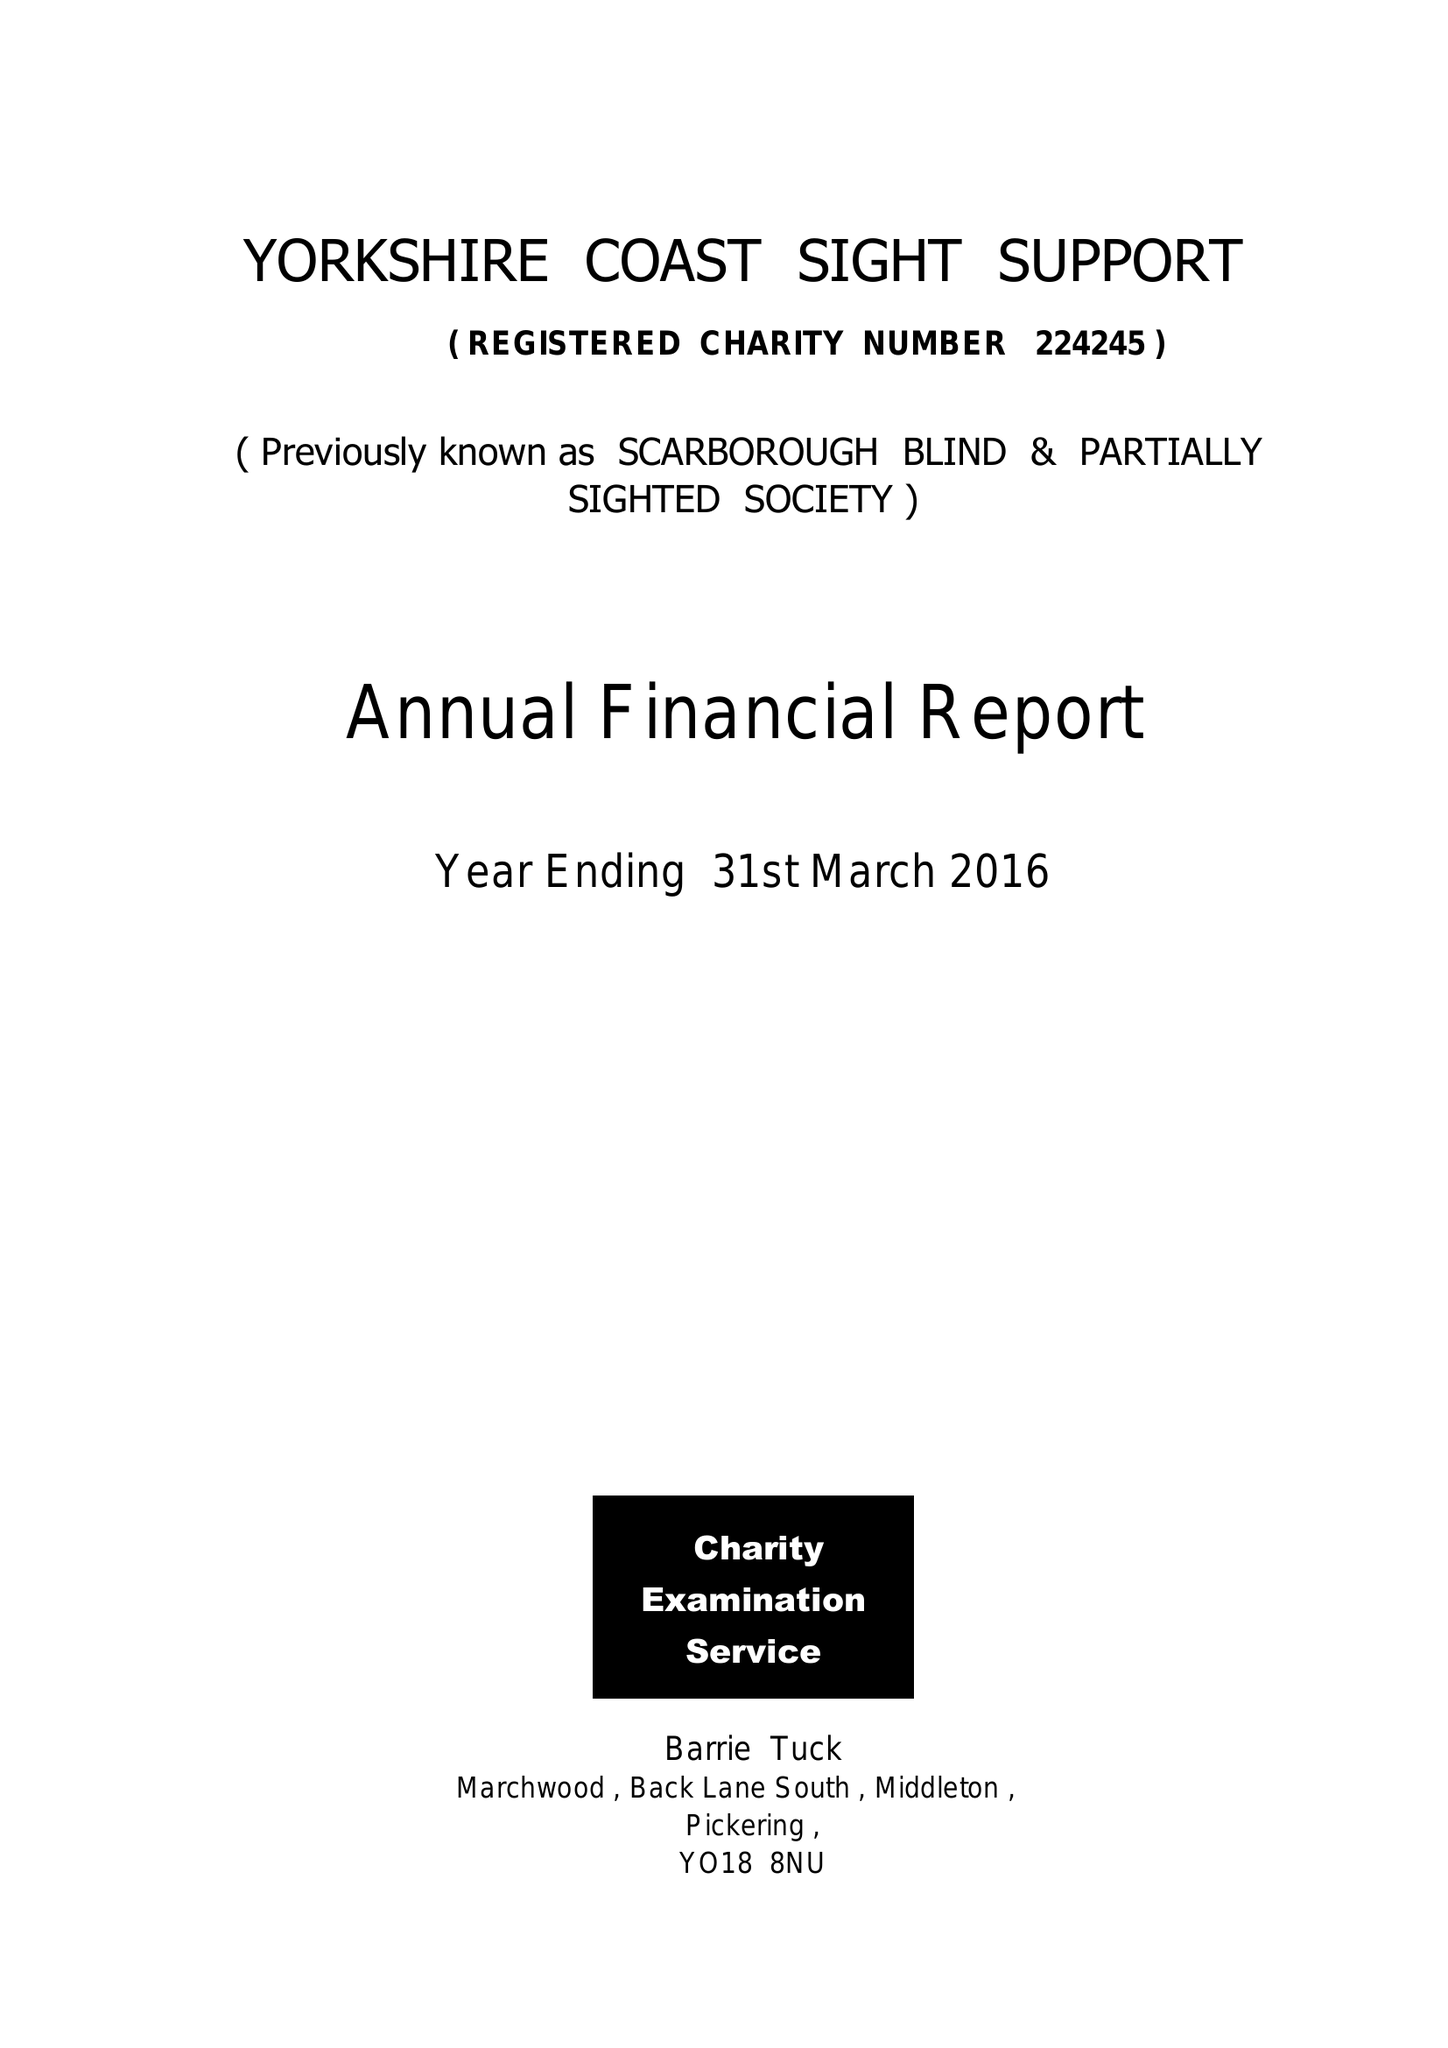What is the value for the address__post_town?
Answer the question using a single word or phrase. SCARBOROUGH 